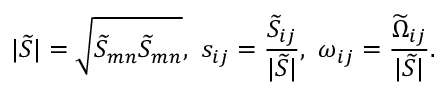<formula> <loc_0><loc_0><loc_500><loc_500>| \widetilde { S } | = \sqrt { { \widetilde { S } } _ { m n } { \widetilde { S } } _ { m n } } , s _ { i j } = \frac { { \widetilde { S } } _ { i j } } { | \widetilde { S } | } , \omega _ { i j } = \frac { { \widetilde { \Omega } } _ { i j } } { | \widetilde { S } | } .</formula> 